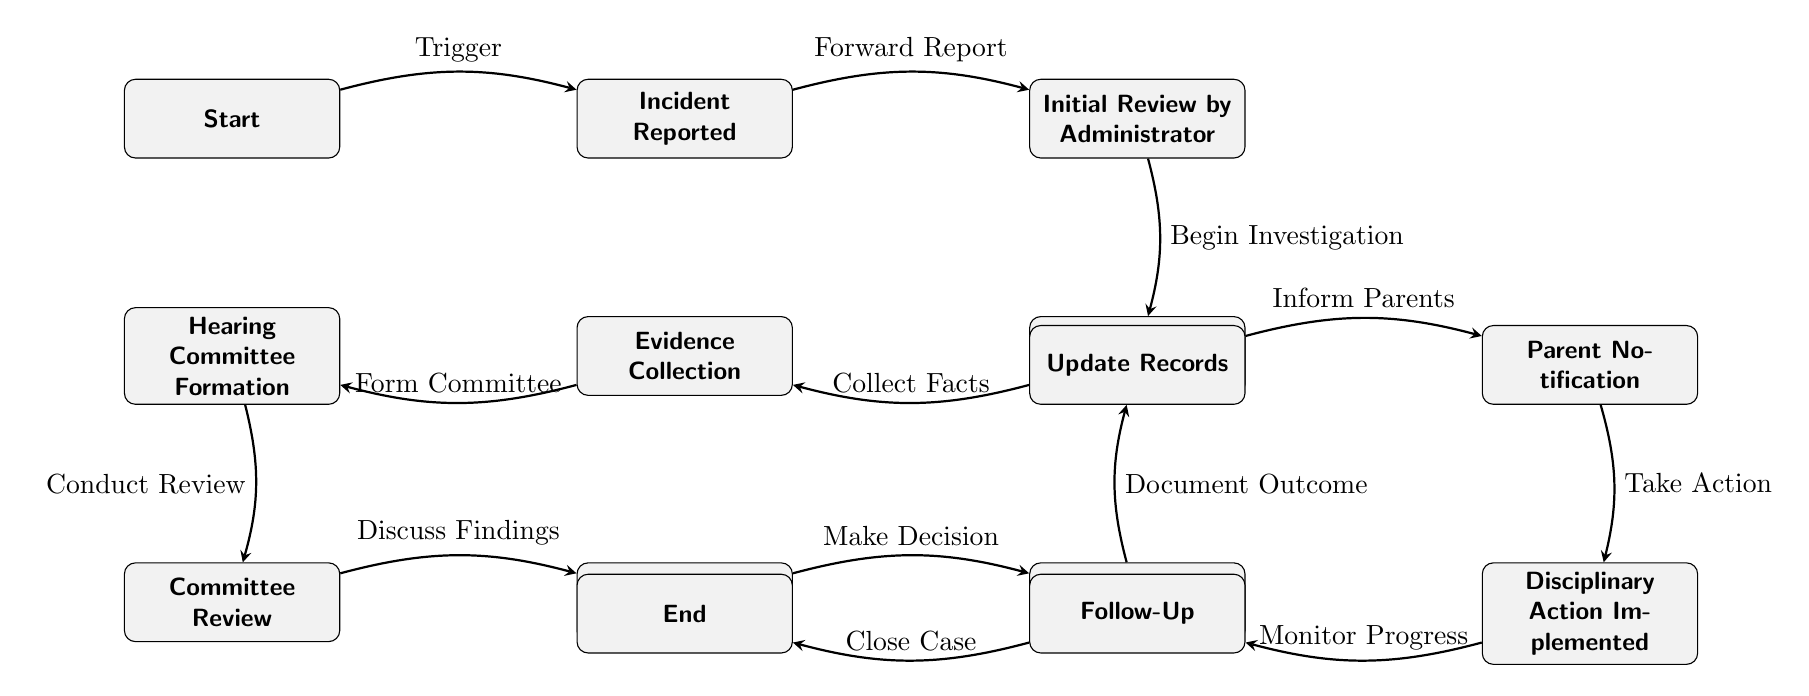What is the first step in the disciplinary procedure? The first node in the diagram is "Start," which indicates the initiation of the disciplinary procedure.
Answer: Start How many total nodes are there in the diagram? By counting each distinct step or action represented within the flowchart, there are 12 nodes identified in the diagram.
Answer: 12 What action follows "Initial Review by Administrator"? The arrow from the "Initial Review by Administrator" node points to "Preliminary Investigation," indicating that the action taken after the review is to start the preliminary investigation.
Answer: Preliminary Investigation Which node comes immediately before "Meeting with Student"? If we trace the flow backward from "Meeting with Student," we identify "Committee Review" as the immediate predecessor node in the sequence of actions.
Answer: Committee Review What is the label on the edge leading to "Final Decision"? The edge that connects to the "Final Decision" node is labeled "Make Decision," which indicates the action that leads to determining the outcome of the disciplinary process.
Answer: Make Decision How do you get to the "Parent Notification" node? To arrive at "Parent Notification," one must first go through "Final Decision," following the flow established by the edges from "Final Decision" to "Update Records," and then directly to "Parent Notification."
Answer: Final Decision What is the last step of the disciplinary procedure? The last node in the flowchart is "End," indicating that the disciplinary procedure culminates in this step after all prior actions are completed.
Answer: End How many actions must occur before disciplinary action is implemented? Before reaching "Disciplinary Action Implemented," there are five preceding actions: "Meeting with Student," "Final Decision," "Update Records," "Parent Notification," and "Take Action," each needing to be completed in succession.
Answer: 5 What node represents the collection of evidence? The node specifically labeled for this function is "Evidence Collection," which emphasizes the importance of gathering information in the investigative process.
Answer: Evidence Collection 